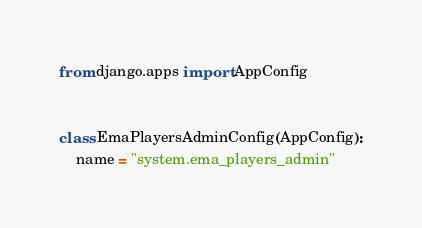Convert code to text. <code><loc_0><loc_0><loc_500><loc_500><_Python_>from django.apps import AppConfig


class EmaPlayersAdminConfig(AppConfig):
    name = "system.ema_players_admin"
</code> 